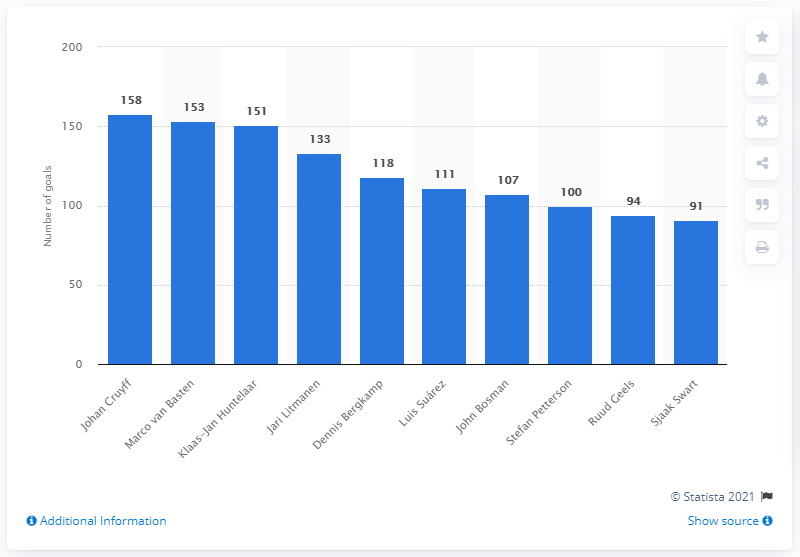Draw attention to some important aspects in this diagram. Marco van Basten, a renowned Dutch soccer player, scored a record 153 goals in 171 appearances for Ajax. During his 233 appearances, Johan Cruyff scored a total of 153 goals, cementing his status as a prolific and talented striker. In 2020, Ajax's all-time top scorer was Johan Cruyff. 